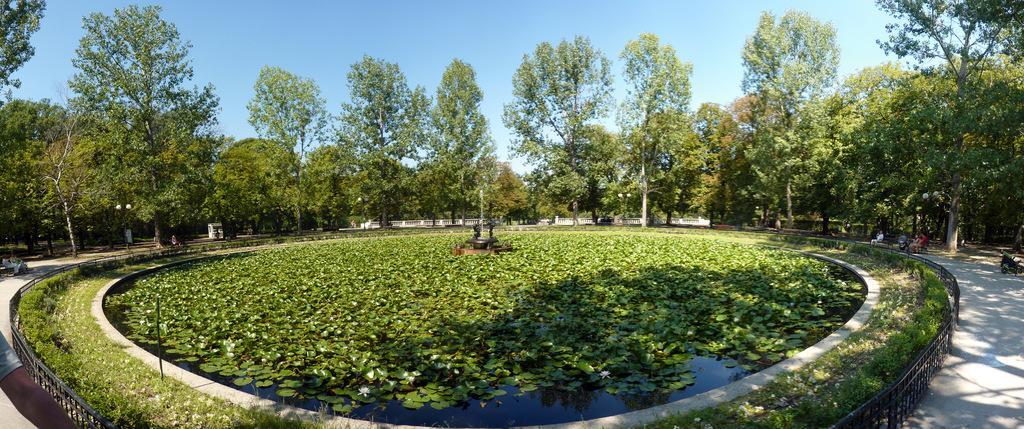Could you give a brief overview of what you see in this image? In this picture, we can see a few people, ground with grass, fencing, water and some leaves, flowers in water, the fountain, trees, and the sky. 